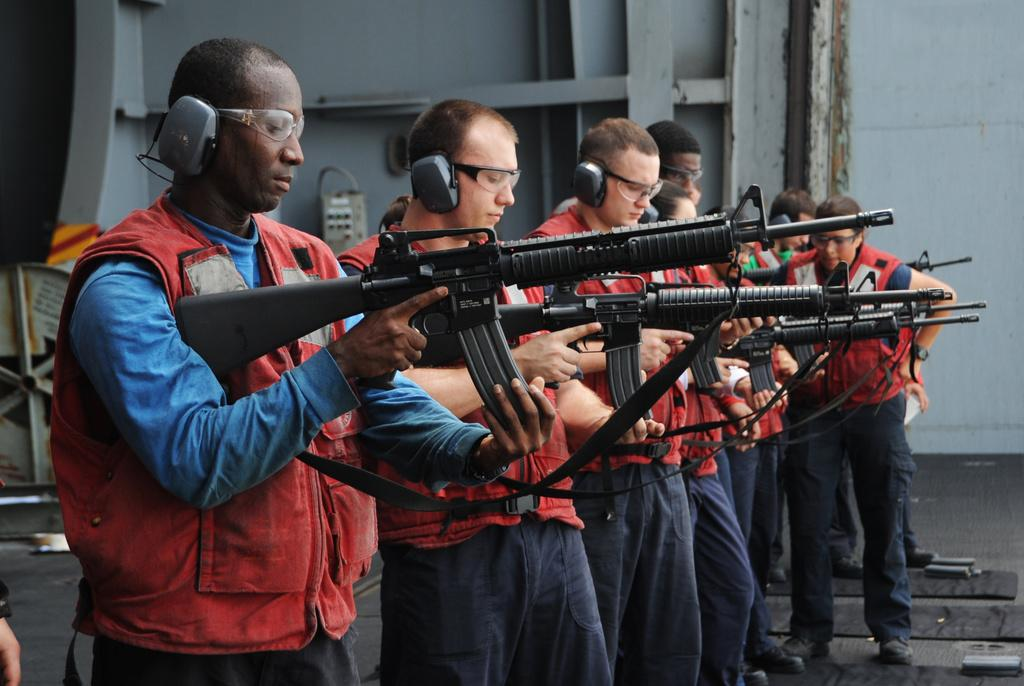What are the people in the image doing? Some people are holding guns in the image. What can be seen in the background of the image? There is a wheel, a device, a wall, a floor, and other objects in the background of the image. What type of noise can be heard coming from the farmer in the image? There is no farmer present in the image, so it's not possible to determine what noise might be heard. 